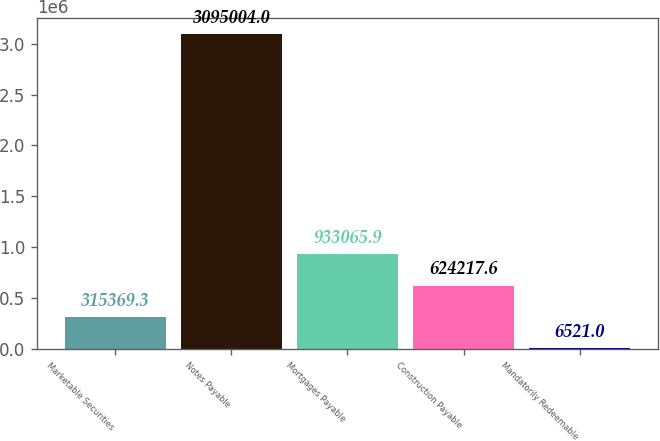Convert chart to OTSL. <chart><loc_0><loc_0><loc_500><loc_500><bar_chart><fcel>Marketable Securities<fcel>Notes Payable<fcel>Mortgages Payable<fcel>Construction Payable<fcel>Mandatorily Redeemable<nl><fcel>315369<fcel>3.095e+06<fcel>933066<fcel>624218<fcel>6521<nl></chart> 